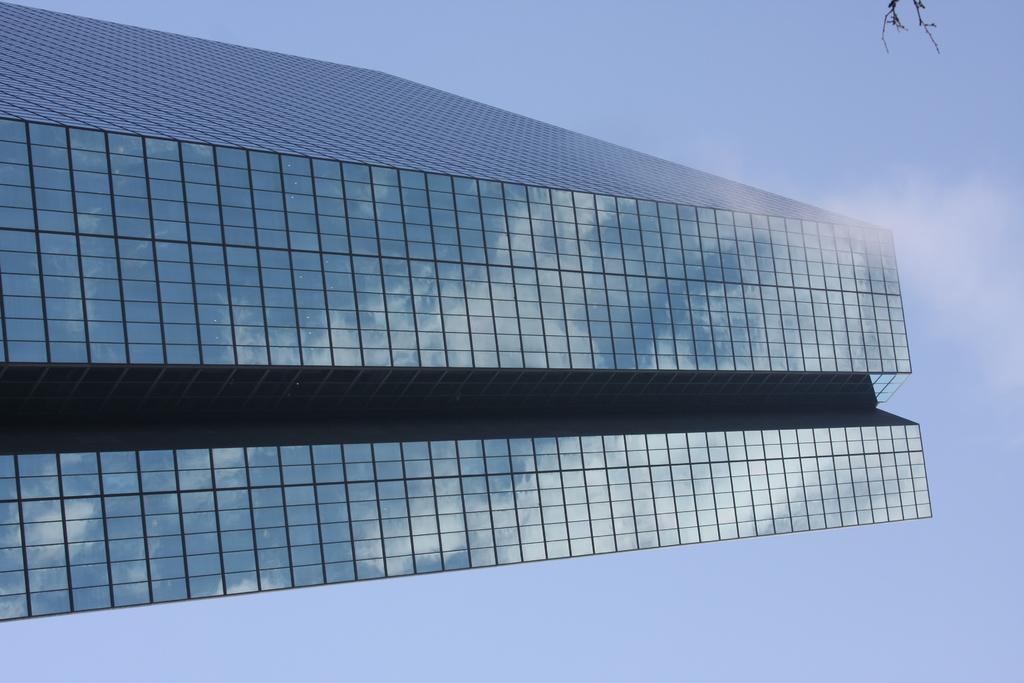How would you summarize this image in a sentence or two? In this image I can see a building in the front and in the background I can see the sky. On the top right side of this image I can see few black colour things. 